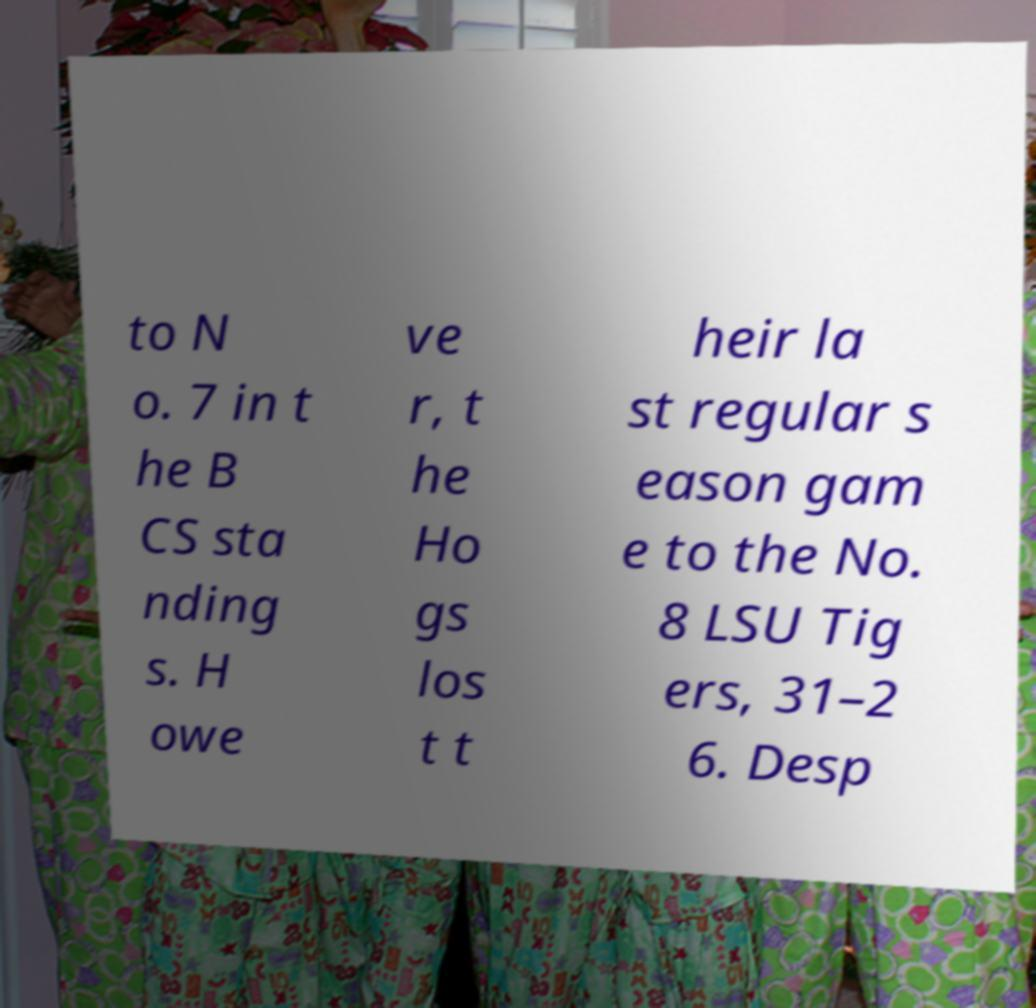Can you read and provide the text displayed in the image?This photo seems to have some interesting text. Can you extract and type it out for me? to N o. 7 in t he B CS sta nding s. H owe ve r, t he Ho gs los t t heir la st regular s eason gam e to the No. 8 LSU Tig ers, 31–2 6. Desp 